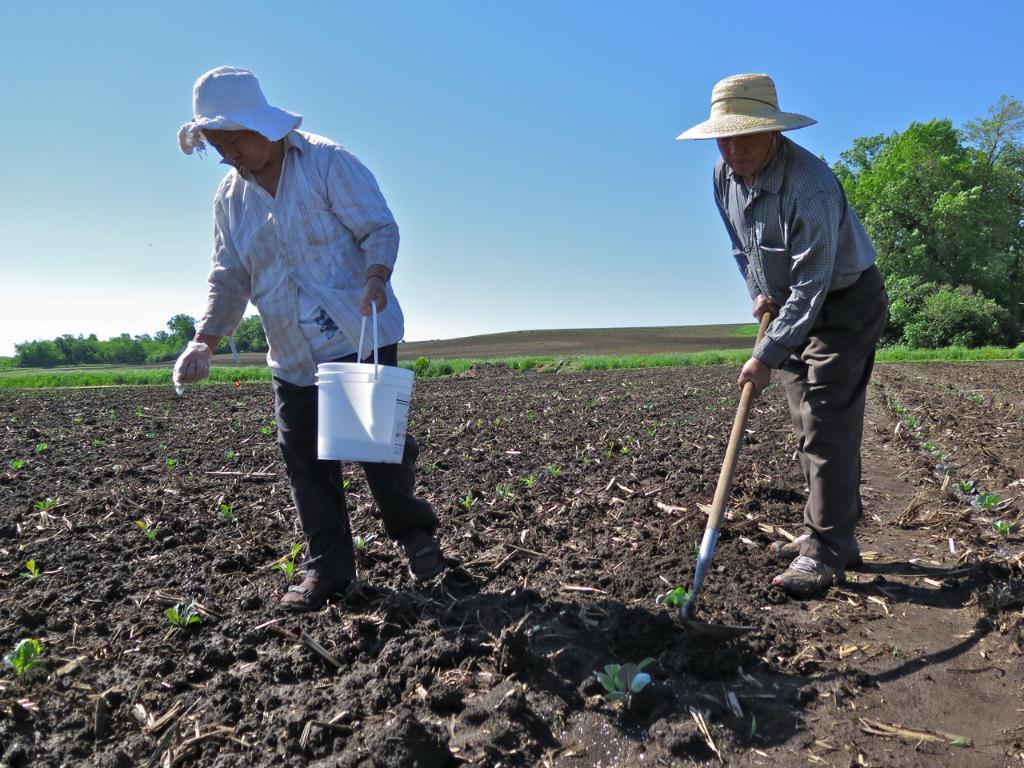Can you describe this image briefly? In this picture there is a man who is standing on the right side of the image and there is another man on the left side of the image, by holding a bucket in his hand, there is grass land in the center of the image and there are trees on the right and left side of the image. 